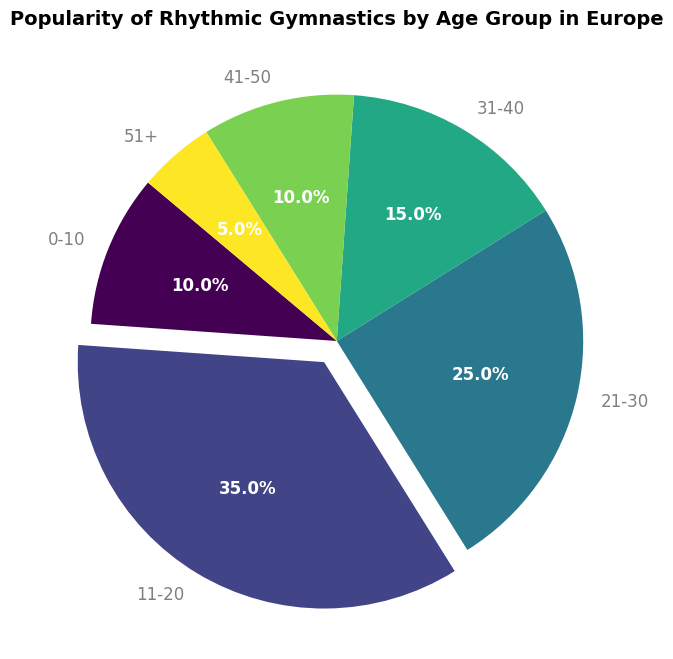What percentage of people aged 11-20 find rhythmic gymnastics popular? The slice for the 11-20 age group shows 35%.
Answer: 35% What is the least popular age group for rhythmic gymnastics? The slice for the 51+ age group is the smallest, indicating it is 5%.
Answer: 51+ Which age group follows the 11-20 age group in terms of popularity? The slice for the 21-30 age group is the next largest after the 11-20 age group, showing 25%.
Answer: 21-30 Sum the popularity percentages of the age groups 0-10, 41-50, and 51+. Adding the percentages: 10% (0-10) + 10% (41-50) + 5% (51+) = 25%.
Answer: 25% How many age groups have a popularity percentage greater than the 10-20 age group? None, as 35% for the 11-20 age group is the highest value among all groups.
Answer: None Compare the popularity percentages of the 21-30 and 31-40 age groups. Which is higher? The slice for the 21-30 age group shows 25%, which is higher than the 31-40 age group's 15%.
Answer: 21-30 What is the total percentage for the age groups 11-20 and 21-30 combined? Adding the percentages: 35% (11-20) + 25% (21-30) = 60%.
Answer: 60% Are there any age groups that equally share the same popularity percentage? The slices for the 0-10 and 41-50 age groups both show 10%.
Answer: Yes, 0-10 and 41-50 What is the difference in popularity percentage between the most and least popular age groups? The most popular (11-20) is 35% and the least popular (51+) is 5%. Difference: 35% - 5% = 30%.
Answer: 30% What age group is represented by the largest slice of the pie chart? The slice for the 11-20 age group is the largest, indicating it has the highest popularity.
Answer: 11-20 